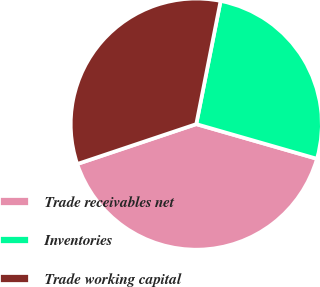<chart> <loc_0><loc_0><loc_500><loc_500><pie_chart><fcel>Trade receivables net<fcel>Inventories<fcel>Trade working capital<nl><fcel>40.4%<fcel>26.35%<fcel>33.25%<nl></chart> 